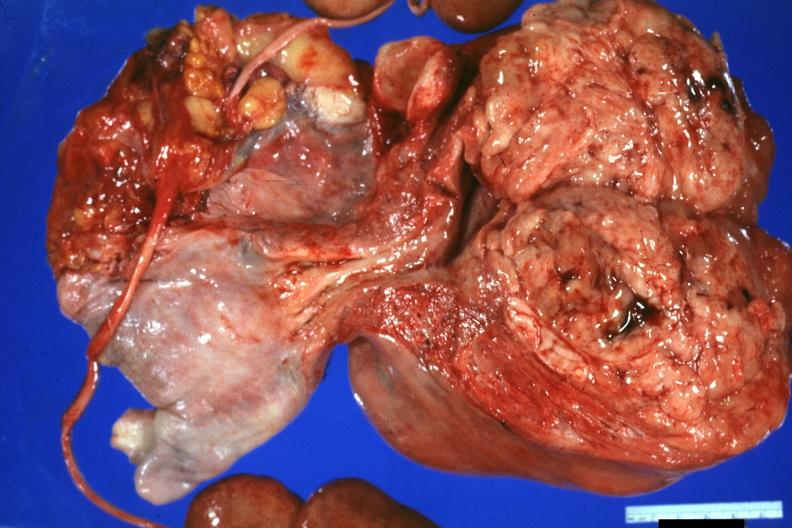what does this image show?
Answer the question using a single word or phrase. Nicely shown large neoplasm with fish flesh cerebriform appearance 